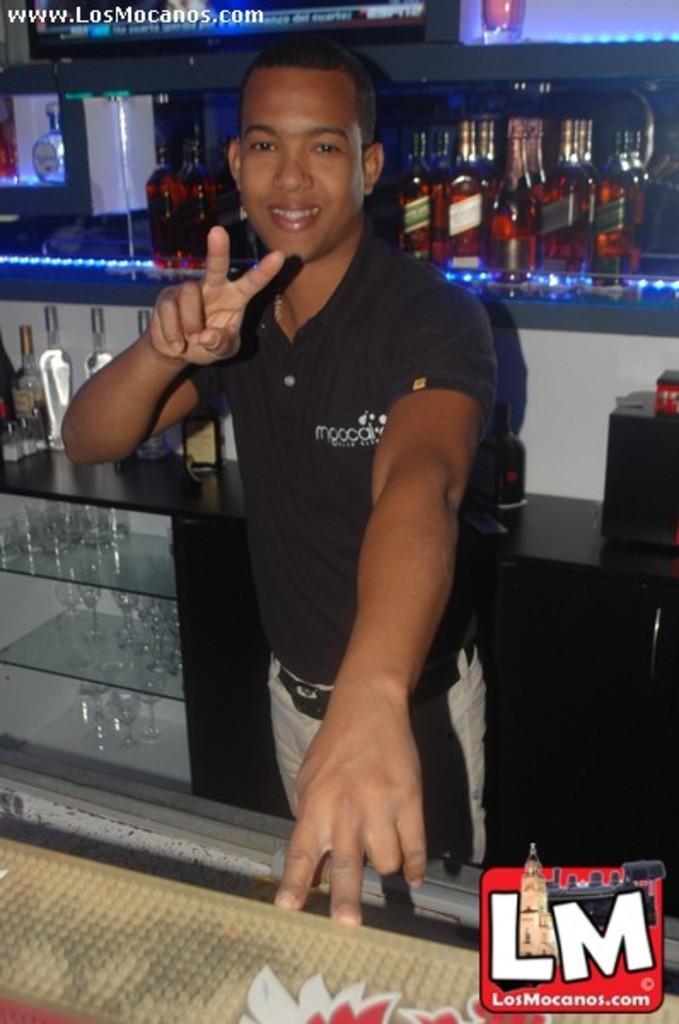In one or two sentences, can you explain what this image depicts? As we can see in the image there is a man wearing black color t shirt. There are bottles, glasses and shelves. 